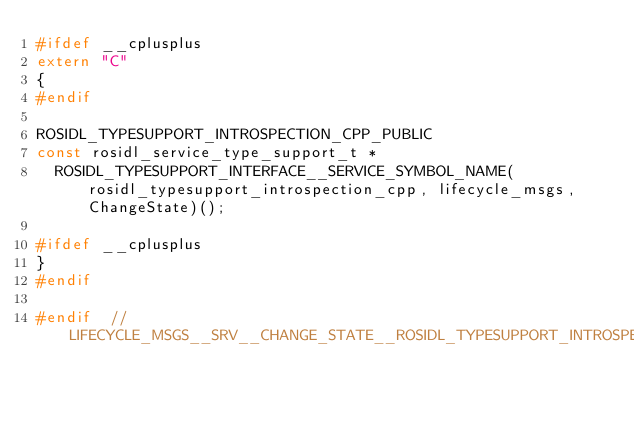Convert code to text. <code><loc_0><loc_0><loc_500><loc_500><_C++_>#ifdef __cplusplus
extern "C"
{
#endif

ROSIDL_TYPESUPPORT_INTROSPECTION_CPP_PUBLIC
const rosidl_service_type_support_t *
  ROSIDL_TYPESUPPORT_INTERFACE__SERVICE_SYMBOL_NAME(rosidl_typesupport_introspection_cpp, lifecycle_msgs, ChangeState)();

#ifdef __cplusplus
}
#endif

#endif  // LIFECYCLE_MSGS__SRV__CHANGE_STATE__ROSIDL_TYPESUPPORT_INTROSPECTION_CPP_HPP_
</code> 